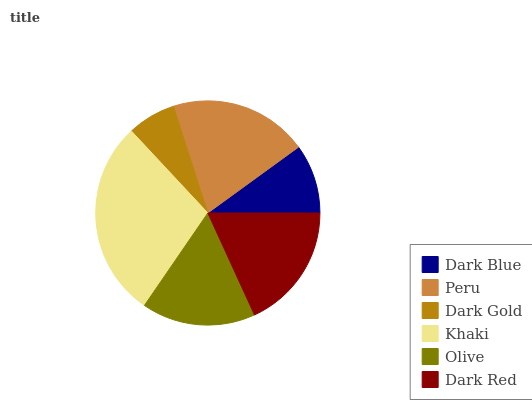Is Dark Gold the minimum?
Answer yes or no. Yes. Is Khaki the maximum?
Answer yes or no. Yes. Is Peru the minimum?
Answer yes or no. No. Is Peru the maximum?
Answer yes or no. No. Is Peru greater than Dark Blue?
Answer yes or no. Yes. Is Dark Blue less than Peru?
Answer yes or no. Yes. Is Dark Blue greater than Peru?
Answer yes or no. No. Is Peru less than Dark Blue?
Answer yes or no. No. Is Dark Red the high median?
Answer yes or no. Yes. Is Olive the low median?
Answer yes or no. Yes. Is Dark Gold the high median?
Answer yes or no. No. Is Dark Red the low median?
Answer yes or no. No. 